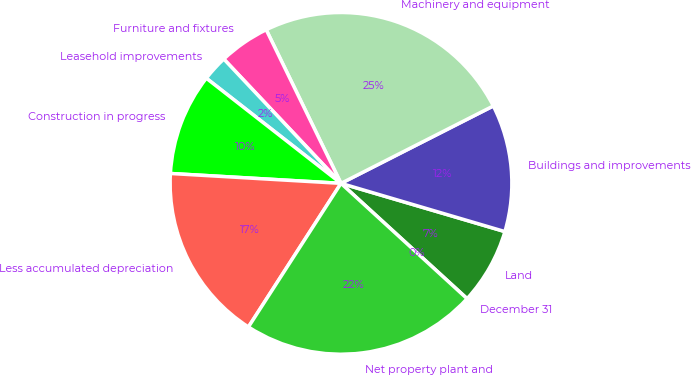Convert chart. <chart><loc_0><loc_0><loc_500><loc_500><pie_chart><fcel>December 31<fcel>Land<fcel>Buildings and improvements<fcel>Machinery and equipment<fcel>Furniture and fixtures<fcel>Leasehold improvements<fcel>Construction in progress<fcel>Less accumulated depreciation<fcel>Net property plant and<nl><fcel>0.01%<fcel>7.23%<fcel>12.04%<fcel>24.73%<fcel>4.82%<fcel>2.42%<fcel>9.63%<fcel>16.81%<fcel>22.32%<nl></chart> 